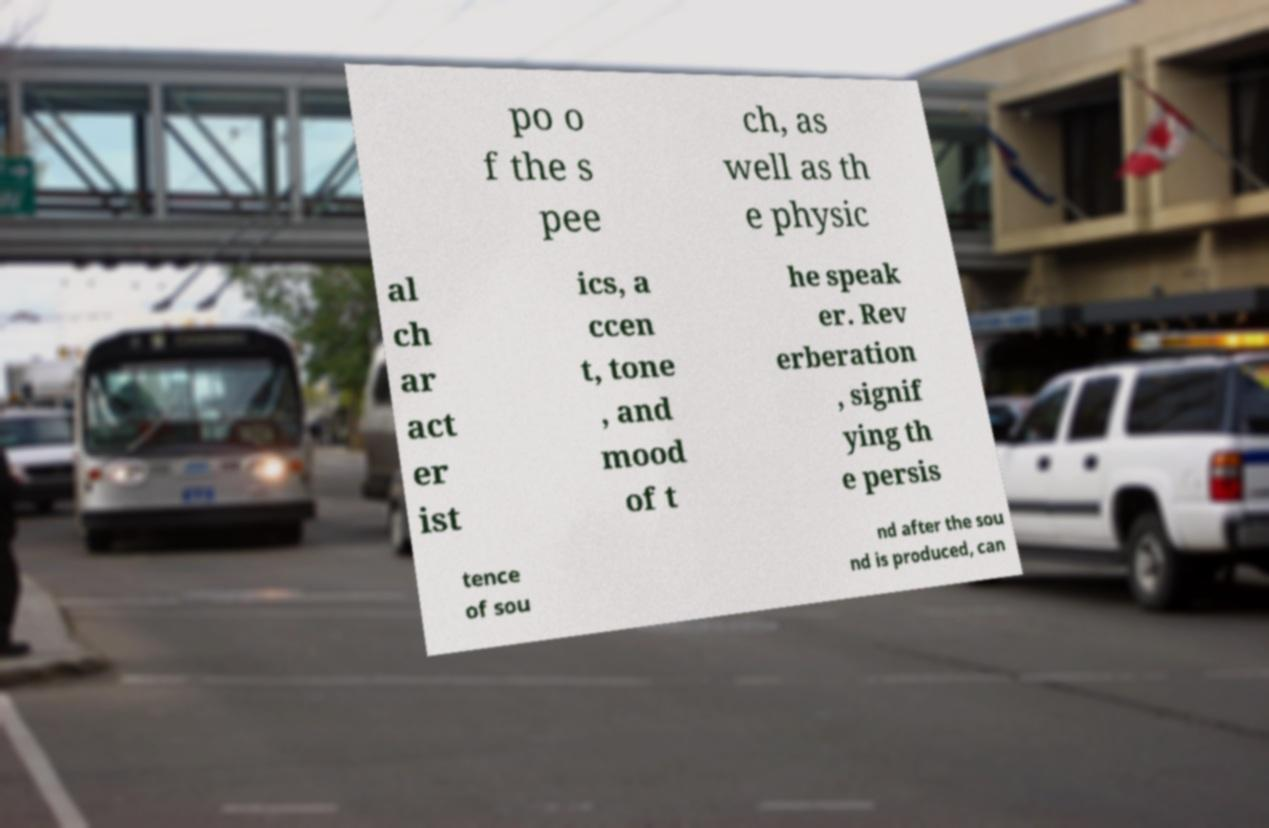Can you accurately transcribe the text from the provided image for me? po o f the s pee ch, as well as th e physic al ch ar act er ist ics, a ccen t, tone , and mood of t he speak er. Rev erberation , signif ying th e persis tence of sou nd after the sou nd is produced, can 